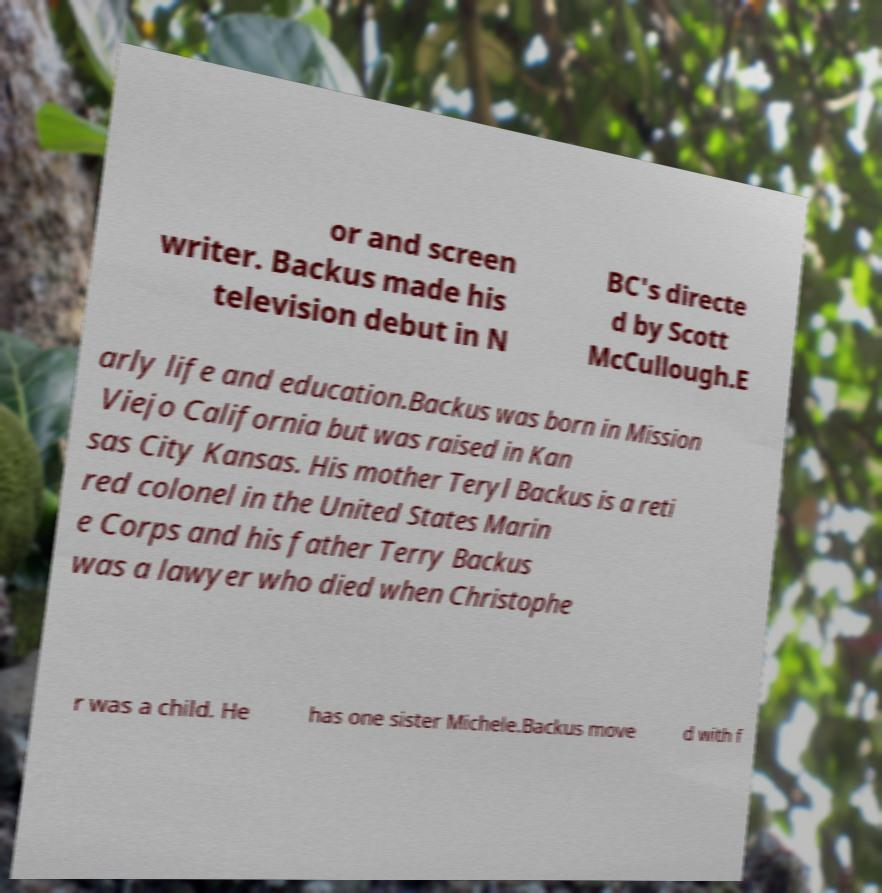Can you accurately transcribe the text from the provided image for me? or and screen writer. Backus made his television debut in N BC's directe d by Scott McCullough.E arly life and education.Backus was born in Mission Viejo California but was raised in Kan sas City Kansas. His mother Teryl Backus is a reti red colonel in the United States Marin e Corps and his father Terry Backus was a lawyer who died when Christophe r was a child. He has one sister Michele.Backus move d with f 